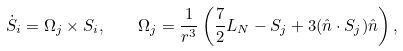Convert formula to latex. <formula><loc_0><loc_0><loc_500><loc_500>\dot { S } _ { i } = \Omega _ { j } \times S _ { i } , \quad \Omega _ { j } = \frac { 1 } { r ^ { 3 } } \left ( \frac { 7 } { 2 } L _ { N } - S _ { j } + 3 ( \hat { n } \cdot S _ { j } ) \hat { n } \right ) ,</formula> 